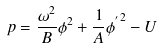<formula> <loc_0><loc_0><loc_500><loc_500>p = \frac { \omega ^ { 2 } } { B } \phi ^ { 2 } + \frac { 1 } { A } { \phi ^ { ^ { \prime } } } ^ { 2 } - U</formula> 